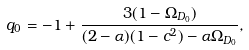Convert formula to latex. <formula><loc_0><loc_0><loc_500><loc_500>q _ { 0 } = - 1 + \frac { 3 ( 1 - \Omega _ { D _ { 0 } } ) } { ( 2 - \alpha ) ( 1 - c ^ { 2 } ) - \alpha \Omega _ { D _ { 0 } } } ,</formula> 